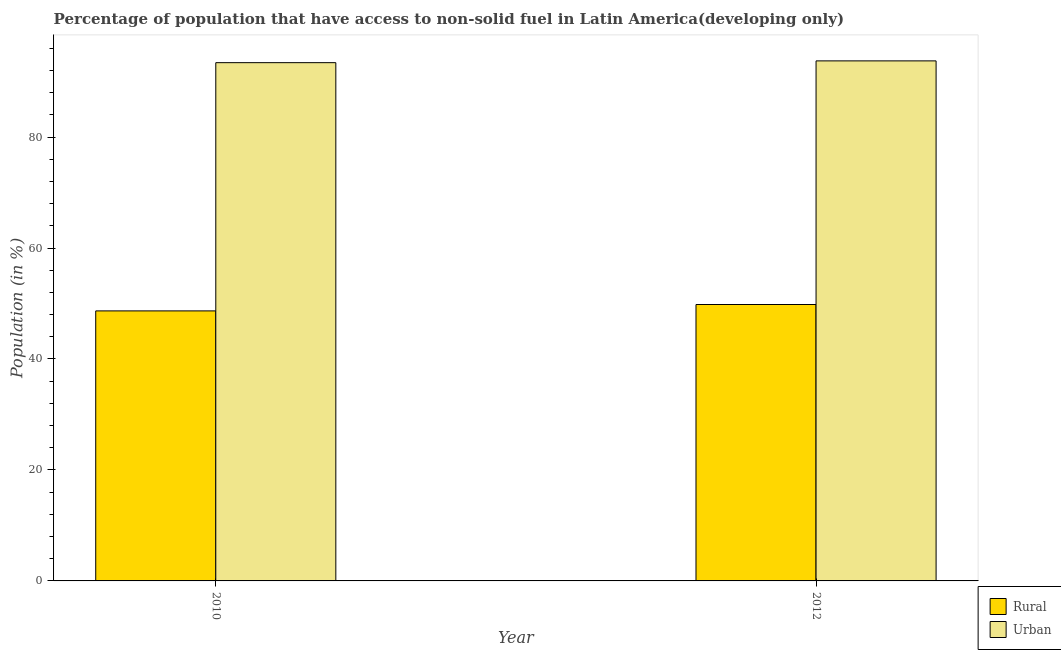How many different coloured bars are there?
Offer a terse response. 2. Are the number of bars per tick equal to the number of legend labels?
Your response must be concise. Yes. How many bars are there on the 1st tick from the right?
Your response must be concise. 2. What is the label of the 1st group of bars from the left?
Your answer should be compact. 2010. What is the urban population in 2010?
Your answer should be very brief. 93.4. Across all years, what is the maximum urban population?
Ensure brevity in your answer.  93.73. Across all years, what is the minimum rural population?
Keep it short and to the point. 48.67. In which year was the urban population maximum?
Give a very brief answer. 2012. In which year was the urban population minimum?
Your answer should be compact. 2010. What is the total rural population in the graph?
Ensure brevity in your answer.  98.48. What is the difference between the urban population in 2010 and that in 2012?
Your answer should be compact. -0.32. What is the difference between the urban population in 2012 and the rural population in 2010?
Make the answer very short. 0.32. What is the average rural population per year?
Make the answer very short. 49.24. In the year 2010, what is the difference between the urban population and rural population?
Ensure brevity in your answer.  0. What is the ratio of the rural population in 2010 to that in 2012?
Provide a short and direct response. 0.98. Is the urban population in 2010 less than that in 2012?
Give a very brief answer. Yes. In how many years, is the urban population greater than the average urban population taken over all years?
Your answer should be very brief. 1. What does the 2nd bar from the left in 2010 represents?
Offer a very short reply. Urban. What does the 1st bar from the right in 2012 represents?
Offer a terse response. Urban. How many bars are there?
Make the answer very short. 4. Are all the bars in the graph horizontal?
Provide a succinct answer. No. What is the difference between two consecutive major ticks on the Y-axis?
Provide a succinct answer. 20. Are the values on the major ticks of Y-axis written in scientific E-notation?
Offer a very short reply. No. Does the graph contain any zero values?
Your answer should be very brief. No. Does the graph contain grids?
Offer a terse response. No. How many legend labels are there?
Provide a short and direct response. 2. What is the title of the graph?
Offer a terse response. Percentage of population that have access to non-solid fuel in Latin America(developing only). What is the Population (in %) in Rural in 2010?
Offer a terse response. 48.67. What is the Population (in %) of Urban in 2010?
Your answer should be very brief. 93.4. What is the Population (in %) in Rural in 2012?
Give a very brief answer. 49.82. What is the Population (in %) of Urban in 2012?
Ensure brevity in your answer.  93.73. Across all years, what is the maximum Population (in %) of Rural?
Keep it short and to the point. 49.82. Across all years, what is the maximum Population (in %) of Urban?
Your answer should be compact. 93.73. Across all years, what is the minimum Population (in %) of Rural?
Give a very brief answer. 48.67. Across all years, what is the minimum Population (in %) in Urban?
Make the answer very short. 93.4. What is the total Population (in %) of Rural in the graph?
Ensure brevity in your answer.  98.48. What is the total Population (in %) of Urban in the graph?
Your answer should be very brief. 187.13. What is the difference between the Population (in %) of Rural in 2010 and that in 2012?
Offer a very short reply. -1.15. What is the difference between the Population (in %) of Urban in 2010 and that in 2012?
Your answer should be very brief. -0.32. What is the difference between the Population (in %) of Rural in 2010 and the Population (in %) of Urban in 2012?
Provide a succinct answer. -45.06. What is the average Population (in %) of Rural per year?
Offer a terse response. 49.24. What is the average Population (in %) in Urban per year?
Give a very brief answer. 93.57. In the year 2010, what is the difference between the Population (in %) of Rural and Population (in %) of Urban?
Your response must be concise. -44.74. In the year 2012, what is the difference between the Population (in %) of Rural and Population (in %) of Urban?
Provide a short and direct response. -43.91. What is the ratio of the Population (in %) in Rural in 2010 to that in 2012?
Offer a very short reply. 0.98. What is the ratio of the Population (in %) of Urban in 2010 to that in 2012?
Ensure brevity in your answer.  1. What is the difference between the highest and the second highest Population (in %) in Rural?
Provide a short and direct response. 1.15. What is the difference between the highest and the second highest Population (in %) in Urban?
Your response must be concise. 0.32. What is the difference between the highest and the lowest Population (in %) in Rural?
Provide a succinct answer. 1.15. What is the difference between the highest and the lowest Population (in %) in Urban?
Provide a short and direct response. 0.32. 